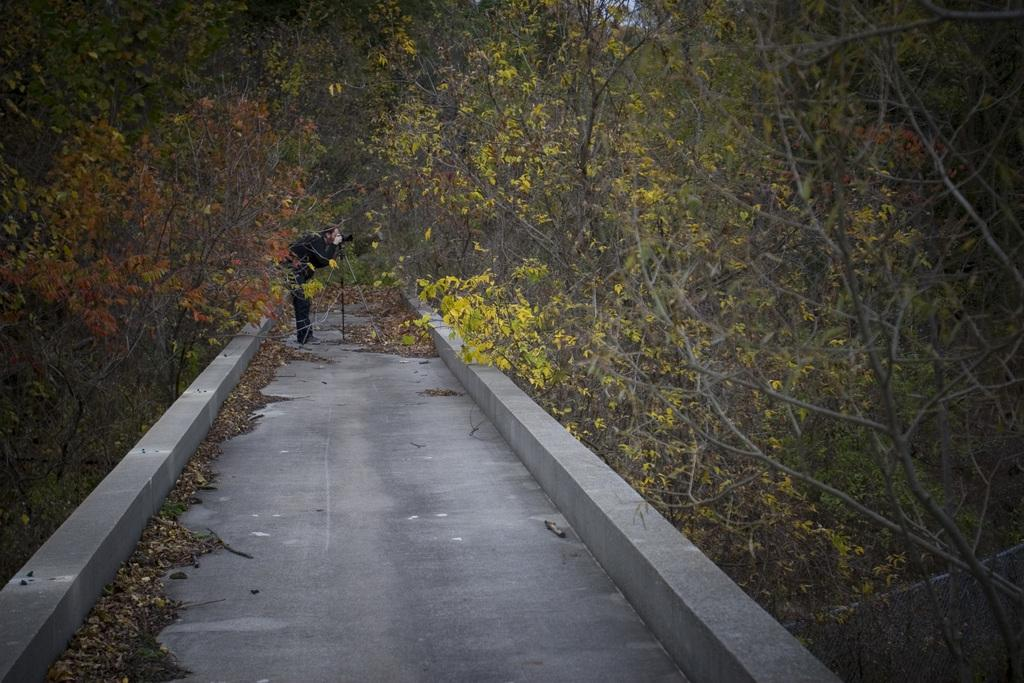What is the main subject of the image? There is a person standing in the center of the image. Where is the person located in the image? The person is on a pathway. What is the person holding in the image? The person is holding a stick. What type of vegetation can be seen in the image? There is a group of trees in the image. What is visible on the ground in the image? There are dried leaves visible in the image. What type of apparel is the person wearing in the image? The provided facts do not mention any specific apparel worn by the person in the image. Can you tell me how many tins are visible in the image? There is no mention of any tins in the image; the facts only mention a person, a stick, trees, and dried leaves. 